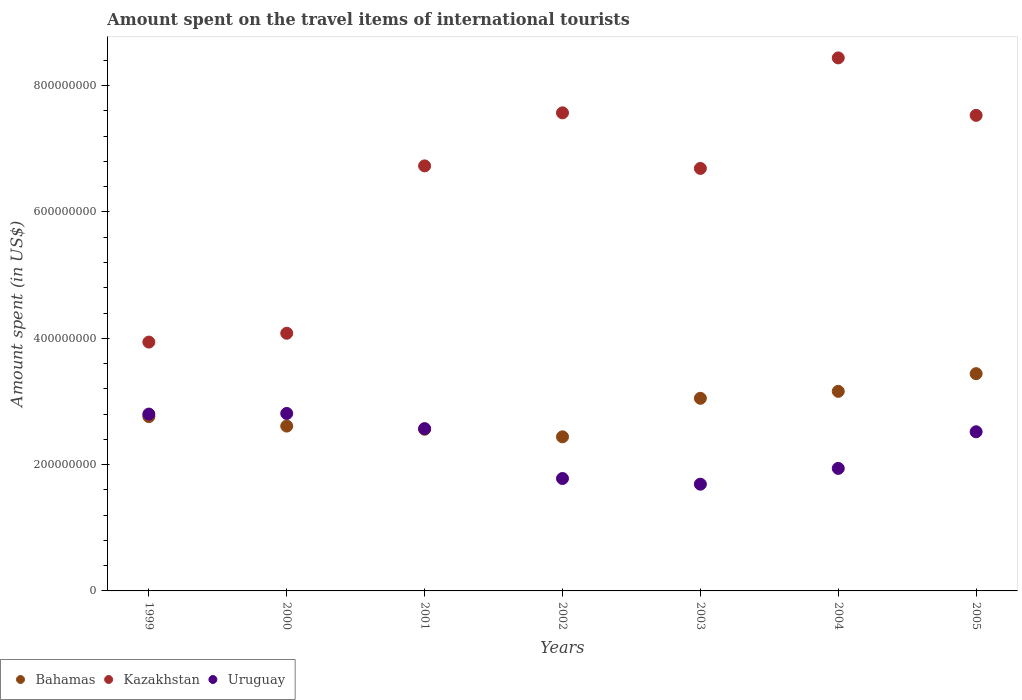How many different coloured dotlines are there?
Ensure brevity in your answer.  3. What is the amount spent on the travel items of international tourists in Kazakhstan in 2005?
Provide a short and direct response. 7.53e+08. Across all years, what is the maximum amount spent on the travel items of international tourists in Bahamas?
Your response must be concise. 3.44e+08. Across all years, what is the minimum amount spent on the travel items of international tourists in Kazakhstan?
Make the answer very short. 3.94e+08. In which year was the amount spent on the travel items of international tourists in Bahamas maximum?
Offer a terse response. 2005. In which year was the amount spent on the travel items of international tourists in Uruguay minimum?
Provide a short and direct response. 2003. What is the total amount spent on the travel items of international tourists in Uruguay in the graph?
Make the answer very short. 1.61e+09. What is the difference between the amount spent on the travel items of international tourists in Kazakhstan in 2000 and that in 2003?
Make the answer very short. -2.61e+08. What is the difference between the amount spent on the travel items of international tourists in Kazakhstan in 2001 and the amount spent on the travel items of international tourists in Bahamas in 2005?
Your answer should be compact. 3.29e+08. What is the average amount spent on the travel items of international tourists in Uruguay per year?
Keep it short and to the point. 2.30e+08. In the year 2000, what is the difference between the amount spent on the travel items of international tourists in Bahamas and amount spent on the travel items of international tourists in Uruguay?
Offer a terse response. -2.00e+07. In how many years, is the amount spent on the travel items of international tourists in Uruguay greater than 760000000 US$?
Your response must be concise. 0. What is the ratio of the amount spent on the travel items of international tourists in Kazakhstan in 1999 to that in 2004?
Offer a terse response. 0.47. What is the difference between the highest and the second highest amount spent on the travel items of international tourists in Kazakhstan?
Offer a very short reply. 8.70e+07. What is the difference between the highest and the lowest amount spent on the travel items of international tourists in Uruguay?
Your response must be concise. 1.12e+08. In how many years, is the amount spent on the travel items of international tourists in Bahamas greater than the average amount spent on the travel items of international tourists in Bahamas taken over all years?
Your answer should be very brief. 3. Is the sum of the amount spent on the travel items of international tourists in Uruguay in 1999 and 2004 greater than the maximum amount spent on the travel items of international tourists in Bahamas across all years?
Ensure brevity in your answer.  Yes. Does the amount spent on the travel items of international tourists in Uruguay monotonically increase over the years?
Provide a succinct answer. No. Is the amount spent on the travel items of international tourists in Bahamas strictly less than the amount spent on the travel items of international tourists in Kazakhstan over the years?
Provide a succinct answer. Yes. How many years are there in the graph?
Your answer should be compact. 7. Does the graph contain any zero values?
Your answer should be compact. No. How many legend labels are there?
Offer a very short reply. 3. What is the title of the graph?
Offer a very short reply. Amount spent on the travel items of international tourists. What is the label or title of the Y-axis?
Your answer should be very brief. Amount spent (in US$). What is the Amount spent (in US$) of Bahamas in 1999?
Provide a succinct answer. 2.76e+08. What is the Amount spent (in US$) in Kazakhstan in 1999?
Ensure brevity in your answer.  3.94e+08. What is the Amount spent (in US$) in Uruguay in 1999?
Keep it short and to the point. 2.80e+08. What is the Amount spent (in US$) of Bahamas in 2000?
Your answer should be very brief. 2.61e+08. What is the Amount spent (in US$) in Kazakhstan in 2000?
Keep it short and to the point. 4.08e+08. What is the Amount spent (in US$) of Uruguay in 2000?
Make the answer very short. 2.81e+08. What is the Amount spent (in US$) in Bahamas in 2001?
Make the answer very short. 2.56e+08. What is the Amount spent (in US$) in Kazakhstan in 2001?
Your answer should be compact. 6.73e+08. What is the Amount spent (in US$) of Uruguay in 2001?
Ensure brevity in your answer.  2.57e+08. What is the Amount spent (in US$) in Bahamas in 2002?
Ensure brevity in your answer.  2.44e+08. What is the Amount spent (in US$) in Kazakhstan in 2002?
Your answer should be very brief. 7.57e+08. What is the Amount spent (in US$) of Uruguay in 2002?
Make the answer very short. 1.78e+08. What is the Amount spent (in US$) in Bahamas in 2003?
Offer a terse response. 3.05e+08. What is the Amount spent (in US$) in Kazakhstan in 2003?
Give a very brief answer. 6.69e+08. What is the Amount spent (in US$) of Uruguay in 2003?
Offer a terse response. 1.69e+08. What is the Amount spent (in US$) in Bahamas in 2004?
Give a very brief answer. 3.16e+08. What is the Amount spent (in US$) of Kazakhstan in 2004?
Offer a very short reply. 8.44e+08. What is the Amount spent (in US$) in Uruguay in 2004?
Your answer should be very brief. 1.94e+08. What is the Amount spent (in US$) of Bahamas in 2005?
Your answer should be very brief. 3.44e+08. What is the Amount spent (in US$) of Kazakhstan in 2005?
Provide a succinct answer. 7.53e+08. What is the Amount spent (in US$) in Uruguay in 2005?
Your answer should be compact. 2.52e+08. Across all years, what is the maximum Amount spent (in US$) of Bahamas?
Ensure brevity in your answer.  3.44e+08. Across all years, what is the maximum Amount spent (in US$) in Kazakhstan?
Your answer should be compact. 8.44e+08. Across all years, what is the maximum Amount spent (in US$) of Uruguay?
Provide a succinct answer. 2.81e+08. Across all years, what is the minimum Amount spent (in US$) of Bahamas?
Give a very brief answer. 2.44e+08. Across all years, what is the minimum Amount spent (in US$) in Kazakhstan?
Offer a very short reply. 3.94e+08. Across all years, what is the minimum Amount spent (in US$) of Uruguay?
Your answer should be compact. 1.69e+08. What is the total Amount spent (in US$) of Bahamas in the graph?
Your response must be concise. 2.00e+09. What is the total Amount spent (in US$) of Kazakhstan in the graph?
Provide a succinct answer. 4.50e+09. What is the total Amount spent (in US$) in Uruguay in the graph?
Make the answer very short. 1.61e+09. What is the difference between the Amount spent (in US$) of Bahamas in 1999 and that in 2000?
Give a very brief answer. 1.50e+07. What is the difference between the Amount spent (in US$) in Kazakhstan in 1999 and that in 2000?
Keep it short and to the point. -1.40e+07. What is the difference between the Amount spent (in US$) of Bahamas in 1999 and that in 2001?
Your answer should be compact. 2.00e+07. What is the difference between the Amount spent (in US$) in Kazakhstan in 1999 and that in 2001?
Your answer should be very brief. -2.79e+08. What is the difference between the Amount spent (in US$) of Uruguay in 1999 and that in 2001?
Provide a succinct answer. 2.30e+07. What is the difference between the Amount spent (in US$) of Bahamas in 1999 and that in 2002?
Your response must be concise. 3.20e+07. What is the difference between the Amount spent (in US$) of Kazakhstan in 1999 and that in 2002?
Keep it short and to the point. -3.63e+08. What is the difference between the Amount spent (in US$) in Uruguay in 1999 and that in 2002?
Ensure brevity in your answer.  1.02e+08. What is the difference between the Amount spent (in US$) of Bahamas in 1999 and that in 2003?
Provide a short and direct response. -2.90e+07. What is the difference between the Amount spent (in US$) in Kazakhstan in 1999 and that in 2003?
Offer a terse response. -2.75e+08. What is the difference between the Amount spent (in US$) in Uruguay in 1999 and that in 2003?
Provide a succinct answer. 1.11e+08. What is the difference between the Amount spent (in US$) in Bahamas in 1999 and that in 2004?
Give a very brief answer. -4.00e+07. What is the difference between the Amount spent (in US$) of Kazakhstan in 1999 and that in 2004?
Your response must be concise. -4.50e+08. What is the difference between the Amount spent (in US$) of Uruguay in 1999 and that in 2004?
Offer a terse response. 8.60e+07. What is the difference between the Amount spent (in US$) of Bahamas in 1999 and that in 2005?
Offer a very short reply. -6.80e+07. What is the difference between the Amount spent (in US$) of Kazakhstan in 1999 and that in 2005?
Ensure brevity in your answer.  -3.59e+08. What is the difference between the Amount spent (in US$) of Uruguay in 1999 and that in 2005?
Provide a succinct answer. 2.80e+07. What is the difference between the Amount spent (in US$) in Kazakhstan in 2000 and that in 2001?
Give a very brief answer. -2.65e+08. What is the difference between the Amount spent (in US$) of Uruguay in 2000 and that in 2001?
Give a very brief answer. 2.40e+07. What is the difference between the Amount spent (in US$) in Bahamas in 2000 and that in 2002?
Make the answer very short. 1.70e+07. What is the difference between the Amount spent (in US$) in Kazakhstan in 2000 and that in 2002?
Offer a terse response. -3.49e+08. What is the difference between the Amount spent (in US$) of Uruguay in 2000 and that in 2002?
Your answer should be very brief. 1.03e+08. What is the difference between the Amount spent (in US$) in Bahamas in 2000 and that in 2003?
Your answer should be compact. -4.40e+07. What is the difference between the Amount spent (in US$) of Kazakhstan in 2000 and that in 2003?
Make the answer very short. -2.61e+08. What is the difference between the Amount spent (in US$) in Uruguay in 2000 and that in 2003?
Your answer should be very brief. 1.12e+08. What is the difference between the Amount spent (in US$) of Bahamas in 2000 and that in 2004?
Your response must be concise. -5.50e+07. What is the difference between the Amount spent (in US$) of Kazakhstan in 2000 and that in 2004?
Give a very brief answer. -4.36e+08. What is the difference between the Amount spent (in US$) in Uruguay in 2000 and that in 2004?
Your answer should be very brief. 8.70e+07. What is the difference between the Amount spent (in US$) in Bahamas in 2000 and that in 2005?
Your response must be concise. -8.30e+07. What is the difference between the Amount spent (in US$) in Kazakhstan in 2000 and that in 2005?
Your response must be concise. -3.45e+08. What is the difference between the Amount spent (in US$) in Uruguay in 2000 and that in 2005?
Keep it short and to the point. 2.90e+07. What is the difference between the Amount spent (in US$) in Kazakhstan in 2001 and that in 2002?
Offer a terse response. -8.40e+07. What is the difference between the Amount spent (in US$) in Uruguay in 2001 and that in 2002?
Ensure brevity in your answer.  7.90e+07. What is the difference between the Amount spent (in US$) of Bahamas in 2001 and that in 2003?
Ensure brevity in your answer.  -4.90e+07. What is the difference between the Amount spent (in US$) in Kazakhstan in 2001 and that in 2003?
Your answer should be very brief. 4.00e+06. What is the difference between the Amount spent (in US$) in Uruguay in 2001 and that in 2003?
Provide a succinct answer. 8.80e+07. What is the difference between the Amount spent (in US$) of Bahamas in 2001 and that in 2004?
Your response must be concise. -6.00e+07. What is the difference between the Amount spent (in US$) in Kazakhstan in 2001 and that in 2004?
Make the answer very short. -1.71e+08. What is the difference between the Amount spent (in US$) of Uruguay in 2001 and that in 2004?
Your answer should be very brief. 6.30e+07. What is the difference between the Amount spent (in US$) of Bahamas in 2001 and that in 2005?
Provide a succinct answer. -8.80e+07. What is the difference between the Amount spent (in US$) of Kazakhstan in 2001 and that in 2005?
Offer a terse response. -8.00e+07. What is the difference between the Amount spent (in US$) in Bahamas in 2002 and that in 2003?
Offer a very short reply. -6.10e+07. What is the difference between the Amount spent (in US$) of Kazakhstan in 2002 and that in 2003?
Make the answer very short. 8.80e+07. What is the difference between the Amount spent (in US$) of Uruguay in 2002 and that in 2003?
Your answer should be compact. 9.00e+06. What is the difference between the Amount spent (in US$) in Bahamas in 2002 and that in 2004?
Make the answer very short. -7.20e+07. What is the difference between the Amount spent (in US$) of Kazakhstan in 2002 and that in 2004?
Your answer should be very brief. -8.70e+07. What is the difference between the Amount spent (in US$) in Uruguay in 2002 and that in 2004?
Make the answer very short. -1.60e+07. What is the difference between the Amount spent (in US$) in Bahamas in 2002 and that in 2005?
Keep it short and to the point. -1.00e+08. What is the difference between the Amount spent (in US$) in Kazakhstan in 2002 and that in 2005?
Your response must be concise. 4.00e+06. What is the difference between the Amount spent (in US$) of Uruguay in 2002 and that in 2005?
Provide a succinct answer. -7.40e+07. What is the difference between the Amount spent (in US$) in Bahamas in 2003 and that in 2004?
Offer a terse response. -1.10e+07. What is the difference between the Amount spent (in US$) of Kazakhstan in 2003 and that in 2004?
Offer a very short reply. -1.75e+08. What is the difference between the Amount spent (in US$) in Uruguay in 2003 and that in 2004?
Offer a very short reply. -2.50e+07. What is the difference between the Amount spent (in US$) of Bahamas in 2003 and that in 2005?
Your answer should be compact. -3.90e+07. What is the difference between the Amount spent (in US$) in Kazakhstan in 2003 and that in 2005?
Your answer should be compact. -8.40e+07. What is the difference between the Amount spent (in US$) of Uruguay in 2003 and that in 2005?
Provide a short and direct response. -8.30e+07. What is the difference between the Amount spent (in US$) in Bahamas in 2004 and that in 2005?
Offer a terse response. -2.80e+07. What is the difference between the Amount spent (in US$) in Kazakhstan in 2004 and that in 2005?
Your answer should be very brief. 9.10e+07. What is the difference between the Amount spent (in US$) in Uruguay in 2004 and that in 2005?
Provide a short and direct response. -5.80e+07. What is the difference between the Amount spent (in US$) in Bahamas in 1999 and the Amount spent (in US$) in Kazakhstan in 2000?
Offer a very short reply. -1.32e+08. What is the difference between the Amount spent (in US$) of Bahamas in 1999 and the Amount spent (in US$) of Uruguay in 2000?
Offer a very short reply. -5.00e+06. What is the difference between the Amount spent (in US$) of Kazakhstan in 1999 and the Amount spent (in US$) of Uruguay in 2000?
Your answer should be very brief. 1.13e+08. What is the difference between the Amount spent (in US$) of Bahamas in 1999 and the Amount spent (in US$) of Kazakhstan in 2001?
Your answer should be very brief. -3.97e+08. What is the difference between the Amount spent (in US$) of Bahamas in 1999 and the Amount spent (in US$) of Uruguay in 2001?
Give a very brief answer. 1.90e+07. What is the difference between the Amount spent (in US$) in Kazakhstan in 1999 and the Amount spent (in US$) in Uruguay in 2001?
Provide a short and direct response. 1.37e+08. What is the difference between the Amount spent (in US$) of Bahamas in 1999 and the Amount spent (in US$) of Kazakhstan in 2002?
Provide a succinct answer. -4.81e+08. What is the difference between the Amount spent (in US$) in Bahamas in 1999 and the Amount spent (in US$) in Uruguay in 2002?
Keep it short and to the point. 9.80e+07. What is the difference between the Amount spent (in US$) of Kazakhstan in 1999 and the Amount spent (in US$) of Uruguay in 2002?
Give a very brief answer. 2.16e+08. What is the difference between the Amount spent (in US$) in Bahamas in 1999 and the Amount spent (in US$) in Kazakhstan in 2003?
Make the answer very short. -3.93e+08. What is the difference between the Amount spent (in US$) of Bahamas in 1999 and the Amount spent (in US$) of Uruguay in 2003?
Your response must be concise. 1.07e+08. What is the difference between the Amount spent (in US$) in Kazakhstan in 1999 and the Amount spent (in US$) in Uruguay in 2003?
Your response must be concise. 2.25e+08. What is the difference between the Amount spent (in US$) of Bahamas in 1999 and the Amount spent (in US$) of Kazakhstan in 2004?
Keep it short and to the point. -5.68e+08. What is the difference between the Amount spent (in US$) of Bahamas in 1999 and the Amount spent (in US$) of Uruguay in 2004?
Provide a short and direct response. 8.20e+07. What is the difference between the Amount spent (in US$) in Bahamas in 1999 and the Amount spent (in US$) in Kazakhstan in 2005?
Your response must be concise. -4.77e+08. What is the difference between the Amount spent (in US$) in Bahamas in 1999 and the Amount spent (in US$) in Uruguay in 2005?
Make the answer very short. 2.40e+07. What is the difference between the Amount spent (in US$) in Kazakhstan in 1999 and the Amount spent (in US$) in Uruguay in 2005?
Keep it short and to the point. 1.42e+08. What is the difference between the Amount spent (in US$) in Bahamas in 2000 and the Amount spent (in US$) in Kazakhstan in 2001?
Offer a terse response. -4.12e+08. What is the difference between the Amount spent (in US$) in Bahamas in 2000 and the Amount spent (in US$) in Uruguay in 2001?
Offer a terse response. 4.00e+06. What is the difference between the Amount spent (in US$) in Kazakhstan in 2000 and the Amount spent (in US$) in Uruguay in 2001?
Offer a terse response. 1.51e+08. What is the difference between the Amount spent (in US$) of Bahamas in 2000 and the Amount spent (in US$) of Kazakhstan in 2002?
Your response must be concise. -4.96e+08. What is the difference between the Amount spent (in US$) in Bahamas in 2000 and the Amount spent (in US$) in Uruguay in 2002?
Provide a short and direct response. 8.30e+07. What is the difference between the Amount spent (in US$) of Kazakhstan in 2000 and the Amount spent (in US$) of Uruguay in 2002?
Make the answer very short. 2.30e+08. What is the difference between the Amount spent (in US$) in Bahamas in 2000 and the Amount spent (in US$) in Kazakhstan in 2003?
Your answer should be compact. -4.08e+08. What is the difference between the Amount spent (in US$) of Bahamas in 2000 and the Amount spent (in US$) of Uruguay in 2003?
Your answer should be very brief. 9.20e+07. What is the difference between the Amount spent (in US$) of Kazakhstan in 2000 and the Amount spent (in US$) of Uruguay in 2003?
Your answer should be compact. 2.39e+08. What is the difference between the Amount spent (in US$) in Bahamas in 2000 and the Amount spent (in US$) in Kazakhstan in 2004?
Make the answer very short. -5.83e+08. What is the difference between the Amount spent (in US$) of Bahamas in 2000 and the Amount spent (in US$) of Uruguay in 2004?
Keep it short and to the point. 6.70e+07. What is the difference between the Amount spent (in US$) of Kazakhstan in 2000 and the Amount spent (in US$) of Uruguay in 2004?
Your answer should be compact. 2.14e+08. What is the difference between the Amount spent (in US$) in Bahamas in 2000 and the Amount spent (in US$) in Kazakhstan in 2005?
Your response must be concise. -4.92e+08. What is the difference between the Amount spent (in US$) in Bahamas in 2000 and the Amount spent (in US$) in Uruguay in 2005?
Provide a succinct answer. 9.00e+06. What is the difference between the Amount spent (in US$) of Kazakhstan in 2000 and the Amount spent (in US$) of Uruguay in 2005?
Give a very brief answer. 1.56e+08. What is the difference between the Amount spent (in US$) of Bahamas in 2001 and the Amount spent (in US$) of Kazakhstan in 2002?
Provide a short and direct response. -5.01e+08. What is the difference between the Amount spent (in US$) in Bahamas in 2001 and the Amount spent (in US$) in Uruguay in 2002?
Keep it short and to the point. 7.80e+07. What is the difference between the Amount spent (in US$) in Kazakhstan in 2001 and the Amount spent (in US$) in Uruguay in 2002?
Keep it short and to the point. 4.95e+08. What is the difference between the Amount spent (in US$) of Bahamas in 2001 and the Amount spent (in US$) of Kazakhstan in 2003?
Offer a terse response. -4.13e+08. What is the difference between the Amount spent (in US$) of Bahamas in 2001 and the Amount spent (in US$) of Uruguay in 2003?
Give a very brief answer. 8.70e+07. What is the difference between the Amount spent (in US$) of Kazakhstan in 2001 and the Amount spent (in US$) of Uruguay in 2003?
Your response must be concise. 5.04e+08. What is the difference between the Amount spent (in US$) in Bahamas in 2001 and the Amount spent (in US$) in Kazakhstan in 2004?
Your answer should be very brief. -5.88e+08. What is the difference between the Amount spent (in US$) in Bahamas in 2001 and the Amount spent (in US$) in Uruguay in 2004?
Ensure brevity in your answer.  6.20e+07. What is the difference between the Amount spent (in US$) in Kazakhstan in 2001 and the Amount spent (in US$) in Uruguay in 2004?
Offer a very short reply. 4.79e+08. What is the difference between the Amount spent (in US$) in Bahamas in 2001 and the Amount spent (in US$) in Kazakhstan in 2005?
Your answer should be very brief. -4.97e+08. What is the difference between the Amount spent (in US$) in Bahamas in 2001 and the Amount spent (in US$) in Uruguay in 2005?
Make the answer very short. 4.00e+06. What is the difference between the Amount spent (in US$) in Kazakhstan in 2001 and the Amount spent (in US$) in Uruguay in 2005?
Provide a succinct answer. 4.21e+08. What is the difference between the Amount spent (in US$) of Bahamas in 2002 and the Amount spent (in US$) of Kazakhstan in 2003?
Offer a terse response. -4.25e+08. What is the difference between the Amount spent (in US$) in Bahamas in 2002 and the Amount spent (in US$) in Uruguay in 2003?
Give a very brief answer. 7.50e+07. What is the difference between the Amount spent (in US$) of Kazakhstan in 2002 and the Amount spent (in US$) of Uruguay in 2003?
Provide a succinct answer. 5.88e+08. What is the difference between the Amount spent (in US$) of Bahamas in 2002 and the Amount spent (in US$) of Kazakhstan in 2004?
Keep it short and to the point. -6.00e+08. What is the difference between the Amount spent (in US$) of Kazakhstan in 2002 and the Amount spent (in US$) of Uruguay in 2004?
Offer a terse response. 5.63e+08. What is the difference between the Amount spent (in US$) in Bahamas in 2002 and the Amount spent (in US$) in Kazakhstan in 2005?
Make the answer very short. -5.09e+08. What is the difference between the Amount spent (in US$) in Bahamas in 2002 and the Amount spent (in US$) in Uruguay in 2005?
Provide a succinct answer. -8.00e+06. What is the difference between the Amount spent (in US$) of Kazakhstan in 2002 and the Amount spent (in US$) of Uruguay in 2005?
Give a very brief answer. 5.05e+08. What is the difference between the Amount spent (in US$) in Bahamas in 2003 and the Amount spent (in US$) in Kazakhstan in 2004?
Your response must be concise. -5.39e+08. What is the difference between the Amount spent (in US$) in Bahamas in 2003 and the Amount spent (in US$) in Uruguay in 2004?
Offer a terse response. 1.11e+08. What is the difference between the Amount spent (in US$) of Kazakhstan in 2003 and the Amount spent (in US$) of Uruguay in 2004?
Keep it short and to the point. 4.75e+08. What is the difference between the Amount spent (in US$) of Bahamas in 2003 and the Amount spent (in US$) of Kazakhstan in 2005?
Give a very brief answer. -4.48e+08. What is the difference between the Amount spent (in US$) of Bahamas in 2003 and the Amount spent (in US$) of Uruguay in 2005?
Ensure brevity in your answer.  5.30e+07. What is the difference between the Amount spent (in US$) of Kazakhstan in 2003 and the Amount spent (in US$) of Uruguay in 2005?
Ensure brevity in your answer.  4.17e+08. What is the difference between the Amount spent (in US$) in Bahamas in 2004 and the Amount spent (in US$) in Kazakhstan in 2005?
Give a very brief answer. -4.37e+08. What is the difference between the Amount spent (in US$) in Bahamas in 2004 and the Amount spent (in US$) in Uruguay in 2005?
Your answer should be very brief. 6.40e+07. What is the difference between the Amount spent (in US$) in Kazakhstan in 2004 and the Amount spent (in US$) in Uruguay in 2005?
Your response must be concise. 5.92e+08. What is the average Amount spent (in US$) of Bahamas per year?
Provide a succinct answer. 2.86e+08. What is the average Amount spent (in US$) of Kazakhstan per year?
Make the answer very short. 6.43e+08. What is the average Amount spent (in US$) in Uruguay per year?
Your response must be concise. 2.30e+08. In the year 1999, what is the difference between the Amount spent (in US$) of Bahamas and Amount spent (in US$) of Kazakhstan?
Ensure brevity in your answer.  -1.18e+08. In the year 1999, what is the difference between the Amount spent (in US$) of Kazakhstan and Amount spent (in US$) of Uruguay?
Keep it short and to the point. 1.14e+08. In the year 2000, what is the difference between the Amount spent (in US$) in Bahamas and Amount spent (in US$) in Kazakhstan?
Give a very brief answer. -1.47e+08. In the year 2000, what is the difference between the Amount spent (in US$) of Bahamas and Amount spent (in US$) of Uruguay?
Your response must be concise. -2.00e+07. In the year 2000, what is the difference between the Amount spent (in US$) in Kazakhstan and Amount spent (in US$) in Uruguay?
Your answer should be compact. 1.27e+08. In the year 2001, what is the difference between the Amount spent (in US$) in Bahamas and Amount spent (in US$) in Kazakhstan?
Your answer should be very brief. -4.17e+08. In the year 2001, what is the difference between the Amount spent (in US$) of Bahamas and Amount spent (in US$) of Uruguay?
Provide a succinct answer. -1.00e+06. In the year 2001, what is the difference between the Amount spent (in US$) of Kazakhstan and Amount spent (in US$) of Uruguay?
Offer a very short reply. 4.16e+08. In the year 2002, what is the difference between the Amount spent (in US$) of Bahamas and Amount spent (in US$) of Kazakhstan?
Keep it short and to the point. -5.13e+08. In the year 2002, what is the difference between the Amount spent (in US$) of Bahamas and Amount spent (in US$) of Uruguay?
Your answer should be compact. 6.60e+07. In the year 2002, what is the difference between the Amount spent (in US$) in Kazakhstan and Amount spent (in US$) in Uruguay?
Keep it short and to the point. 5.79e+08. In the year 2003, what is the difference between the Amount spent (in US$) of Bahamas and Amount spent (in US$) of Kazakhstan?
Offer a terse response. -3.64e+08. In the year 2003, what is the difference between the Amount spent (in US$) of Bahamas and Amount spent (in US$) of Uruguay?
Your answer should be compact. 1.36e+08. In the year 2004, what is the difference between the Amount spent (in US$) in Bahamas and Amount spent (in US$) in Kazakhstan?
Your answer should be very brief. -5.28e+08. In the year 2004, what is the difference between the Amount spent (in US$) of Bahamas and Amount spent (in US$) of Uruguay?
Give a very brief answer. 1.22e+08. In the year 2004, what is the difference between the Amount spent (in US$) in Kazakhstan and Amount spent (in US$) in Uruguay?
Give a very brief answer. 6.50e+08. In the year 2005, what is the difference between the Amount spent (in US$) of Bahamas and Amount spent (in US$) of Kazakhstan?
Offer a terse response. -4.09e+08. In the year 2005, what is the difference between the Amount spent (in US$) of Bahamas and Amount spent (in US$) of Uruguay?
Provide a succinct answer. 9.20e+07. In the year 2005, what is the difference between the Amount spent (in US$) of Kazakhstan and Amount spent (in US$) of Uruguay?
Your response must be concise. 5.01e+08. What is the ratio of the Amount spent (in US$) in Bahamas in 1999 to that in 2000?
Your answer should be compact. 1.06. What is the ratio of the Amount spent (in US$) in Kazakhstan in 1999 to that in 2000?
Keep it short and to the point. 0.97. What is the ratio of the Amount spent (in US$) in Bahamas in 1999 to that in 2001?
Keep it short and to the point. 1.08. What is the ratio of the Amount spent (in US$) of Kazakhstan in 1999 to that in 2001?
Offer a very short reply. 0.59. What is the ratio of the Amount spent (in US$) of Uruguay in 1999 to that in 2001?
Make the answer very short. 1.09. What is the ratio of the Amount spent (in US$) of Bahamas in 1999 to that in 2002?
Make the answer very short. 1.13. What is the ratio of the Amount spent (in US$) in Kazakhstan in 1999 to that in 2002?
Provide a succinct answer. 0.52. What is the ratio of the Amount spent (in US$) of Uruguay in 1999 to that in 2002?
Make the answer very short. 1.57. What is the ratio of the Amount spent (in US$) in Bahamas in 1999 to that in 2003?
Make the answer very short. 0.9. What is the ratio of the Amount spent (in US$) in Kazakhstan in 1999 to that in 2003?
Offer a very short reply. 0.59. What is the ratio of the Amount spent (in US$) of Uruguay in 1999 to that in 2003?
Ensure brevity in your answer.  1.66. What is the ratio of the Amount spent (in US$) in Bahamas in 1999 to that in 2004?
Provide a short and direct response. 0.87. What is the ratio of the Amount spent (in US$) in Kazakhstan in 1999 to that in 2004?
Your answer should be very brief. 0.47. What is the ratio of the Amount spent (in US$) in Uruguay in 1999 to that in 2004?
Ensure brevity in your answer.  1.44. What is the ratio of the Amount spent (in US$) in Bahamas in 1999 to that in 2005?
Provide a succinct answer. 0.8. What is the ratio of the Amount spent (in US$) of Kazakhstan in 1999 to that in 2005?
Make the answer very short. 0.52. What is the ratio of the Amount spent (in US$) of Bahamas in 2000 to that in 2001?
Ensure brevity in your answer.  1.02. What is the ratio of the Amount spent (in US$) of Kazakhstan in 2000 to that in 2001?
Ensure brevity in your answer.  0.61. What is the ratio of the Amount spent (in US$) in Uruguay in 2000 to that in 2001?
Your answer should be very brief. 1.09. What is the ratio of the Amount spent (in US$) in Bahamas in 2000 to that in 2002?
Ensure brevity in your answer.  1.07. What is the ratio of the Amount spent (in US$) in Kazakhstan in 2000 to that in 2002?
Your answer should be compact. 0.54. What is the ratio of the Amount spent (in US$) in Uruguay in 2000 to that in 2002?
Provide a short and direct response. 1.58. What is the ratio of the Amount spent (in US$) in Bahamas in 2000 to that in 2003?
Ensure brevity in your answer.  0.86. What is the ratio of the Amount spent (in US$) of Kazakhstan in 2000 to that in 2003?
Ensure brevity in your answer.  0.61. What is the ratio of the Amount spent (in US$) of Uruguay in 2000 to that in 2003?
Provide a short and direct response. 1.66. What is the ratio of the Amount spent (in US$) of Bahamas in 2000 to that in 2004?
Ensure brevity in your answer.  0.83. What is the ratio of the Amount spent (in US$) in Kazakhstan in 2000 to that in 2004?
Your answer should be compact. 0.48. What is the ratio of the Amount spent (in US$) of Uruguay in 2000 to that in 2004?
Your answer should be very brief. 1.45. What is the ratio of the Amount spent (in US$) of Bahamas in 2000 to that in 2005?
Your response must be concise. 0.76. What is the ratio of the Amount spent (in US$) of Kazakhstan in 2000 to that in 2005?
Keep it short and to the point. 0.54. What is the ratio of the Amount spent (in US$) in Uruguay in 2000 to that in 2005?
Give a very brief answer. 1.12. What is the ratio of the Amount spent (in US$) in Bahamas in 2001 to that in 2002?
Keep it short and to the point. 1.05. What is the ratio of the Amount spent (in US$) in Kazakhstan in 2001 to that in 2002?
Your answer should be very brief. 0.89. What is the ratio of the Amount spent (in US$) of Uruguay in 2001 to that in 2002?
Keep it short and to the point. 1.44. What is the ratio of the Amount spent (in US$) in Bahamas in 2001 to that in 2003?
Offer a terse response. 0.84. What is the ratio of the Amount spent (in US$) in Uruguay in 2001 to that in 2003?
Provide a short and direct response. 1.52. What is the ratio of the Amount spent (in US$) of Bahamas in 2001 to that in 2004?
Your answer should be very brief. 0.81. What is the ratio of the Amount spent (in US$) in Kazakhstan in 2001 to that in 2004?
Your answer should be very brief. 0.8. What is the ratio of the Amount spent (in US$) in Uruguay in 2001 to that in 2004?
Give a very brief answer. 1.32. What is the ratio of the Amount spent (in US$) of Bahamas in 2001 to that in 2005?
Offer a terse response. 0.74. What is the ratio of the Amount spent (in US$) of Kazakhstan in 2001 to that in 2005?
Your response must be concise. 0.89. What is the ratio of the Amount spent (in US$) of Uruguay in 2001 to that in 2005?
Offer a very short reply. 1.02. What is the ratio of the Amount spent (in US$) of Bahamas in 2002 to that in 2003?
Your answer should be very brief. 0.8. What is the ratio of the Amount spent (in US$) of Kazakhstan in 2002 to that in 2003?
Your response must be concise. 1.13. What is the ratio of the Amount spent (in US$) of Uruguay in 2002 to that in 2003?
Your response must be concise. 1.05. What is the ratio of the Amount spent (in US$) in Bahamas in 2002 to that in 2004?
Give a very brief answer. 0.77. What is the ratio of the Amount spent (in US$) of Kazakhstan in 2002 to that in 2004?
Provide a succinct answer. 0.9. What is the ratio of the Amount spent (in US$) of Uruguay in 2002 to that in 2004?
Provide a short and direct response. 0.92. What is the ratio of the Amount spent (in US$) of Bahamas in 2002 to that in 2005?
Offer a terse response. 0.71. What is the ratio of the Amount spent (in US$) of Uruguay in 2002 to that in 2005?
Your response must be concise. 0.71. What is the ratio of the Amount spent (in US$) in Bahamas in 2003 to that in 2004?
Make the answer very short. 0.97. What is the ratio of the Amount spent (in US$) of Kazakhstan in 2003 to that in 2004?
Your answer should be compact. 0.79. What is the ratio of the Amount spent (in US$) in Uruguay in 2003 to that in 2004?
Give a very brief answer. 0.87. What is the ratio of the Amount spent (in US$) of Bahamas in 2003 to that in 2005?
Give a very brief answer. 0.89. What is the ratio of the Amount spent (in US$) in Kazakhstan in 2003 to that in 2005?
Give a very brief answer. 0.89. What is the ratio of the Amount spent (in US$) of Uruguay in 2003 to that in 2005?
Keep it short and to the point. 0.67. What is the ratio of the Amount spent (in US$) of Bahamas in 2004 to that in 2005?
Offer a very short reply. 0.92. What is the ratio of the Amount spent (in US$) in Kazakhstan in 2004 to that in 2005?
Ensure brevity in your answer.  1.12. What is the ratio of the Amount spent (in US$) of Uruguay in 2004 to that in 2005?
Offer a very short reply. 0.77. What is the difference between the highest and the second highest Amount spent (in US$) of Bahamas?
Keep it short and to the point. 2.80e+07. What is the difference between the highest and the second highest Amount spent (in US$) in Kazakhstan?
Your answer should be very brief. 8.70e+07. What is the difference between the highest and the lowest Amount spent (in US$) of Kazakhstan?
Your answer should be very brief. 4.50e+08. What is the difference between the highest and the lowest Amount spent (in US$) of Uruguay?
Offer a very short reply. 1.12e+08. 